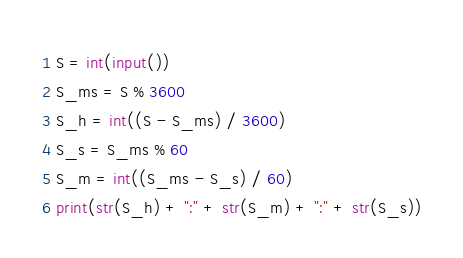Convert code to text. <code><loc_0><loc_0><loc_500><loc_500><_Python_>S = int(input())
S_ms = S % 3600
S_h = int((S - S_ms) / 3600)
S_s = S_ms % 60
S_m = int((S_ms - S_s) / 60)
print(str(S_h) + ":" + str(S_m) + ":" + str(S_s))
</code> 